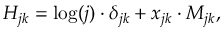Convert formula to latex. <formula><loc_0><loc_0><loc_500><loc_500>H _ { j k } = \log ( j ) \cdot \delta _ { j k } + x _ { j k } \cdot M _ { j k } ,</formula> 